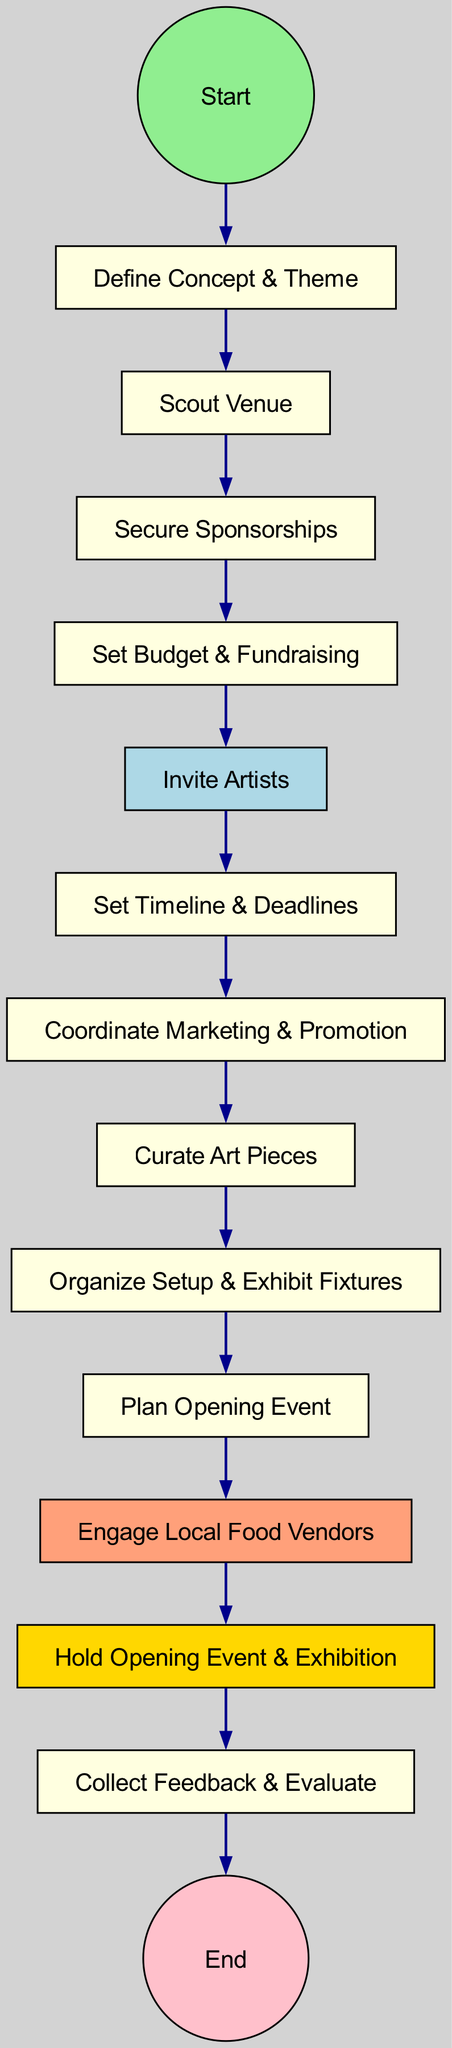What is the first activity in the diagram? The first activity listed in the diagram, which connects to the "Start" event, is "Define Concept & Theme." This is identified by examining the node that follows the starting event, denoting the initial task in the process.
Answer: Define Concept & Theme How many activities are there in total? By counting all the activity nodes in the diagram, excluding the start and end events, there are 13 activities in total. The activities are listed sequentially from "Define Concept & Theme" to "Collect Feedback & Evaluate."
Answer: 13 What is the last activity before the end event? The last activity that precedes the end event is "Collect Feedback & Evaluate." This can be seen as the final step in the process before reaching the termination of the activity flow.
Answer: Collect Feedback & Evaluate Which activity is highlighted in light blue? The activity highlighted in light blue is "Invite Artists." This is noted specifically because the node's background color visually distinguishes it from the rest, indicating its significance in the process.
Answer: Invite Artists What is the relationship between "Engage Local Food Vendors" and "Hold Opening Event & Exhibition"? "Engage Local Food Vendors" is an activity that occurs before "Hold Opening Event & Exhibition." In the diagram's flow, you can trace the connection from the former activity to the latter, indicating a sequential relationship where engaging vendors is prerequisite to holding the event.
Answer: Sequential relationship How many edges are there in the diagram? The total number of edges corresponds to the connections between each activity and can be determined by counting the directed connectors between nodes. The diagram shows 14 edges, linking each of the 13 activities plus the connection from the start event.
Answer: 14 What type of diagram is this? The diagram is classified as an "Activity Diagram," which focuses on demonstrating the flow of actions and the sequence of tasks involved in a process. This is evident from its structure and depiction of activities and decision points.
Answer: Activity Diagram What is the main theme of the exhibition planning process? The main theme is "Organizing a Local Art Exhibition." This can be inferred from the context of the activities listed in the diagram, which revolve around various aspects of planning and executing an art exhibition specifically in a local setting.
Answer: Organizing a Local Art Exhibition 